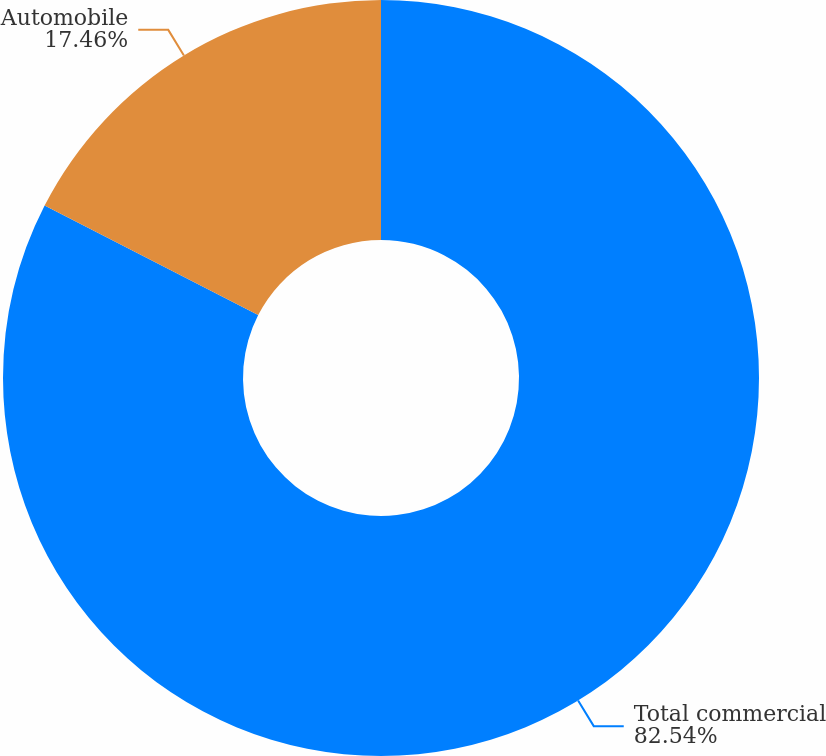Convert chart. <chart><loc_0><loc_0><loc_500><loc_500><pie_chart><fcel>Total commercial<fcel>Automobile<nl><fcel>82.54%<fcel>17.46%<nl></chart> 